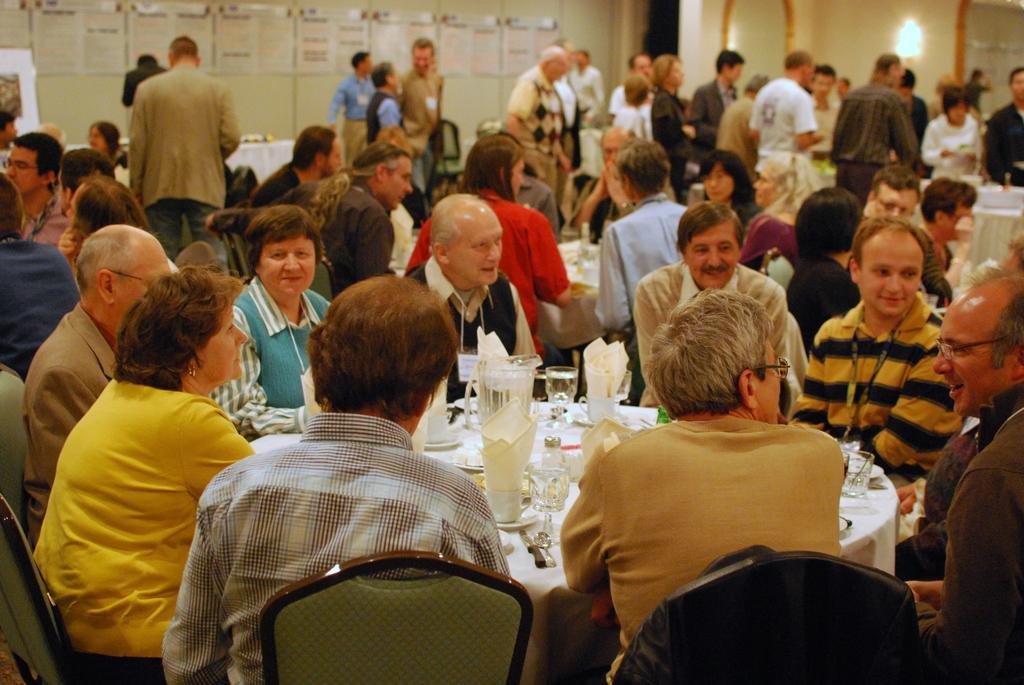Can you describe this image briefly? There is a group of people. Some persons are sitting on a chairs and some persons are standing. There is a table. There is a glass,bottle,tissue on a table. We can see in background wall,poster and door. 